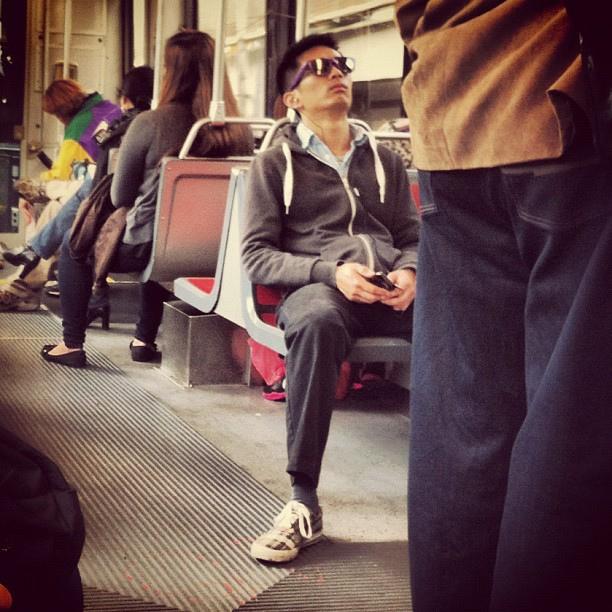What are these people waiting on?
Give a very brief answer. Bus stop. The young man with the sunglasses is excited?
Quick response, please. No. What design pattern is the man's shoes?
Give a very brief answer. Plaid. Are there any bicycles in this picture?
Concise answer only. No. What are the people inside of?
Keep it brief. Bus. Is the mans blue jacket zipped up or unzipped?
Give a very brief answer. Zipped. Is the man holding a drink?
Write a very short answer. No. 